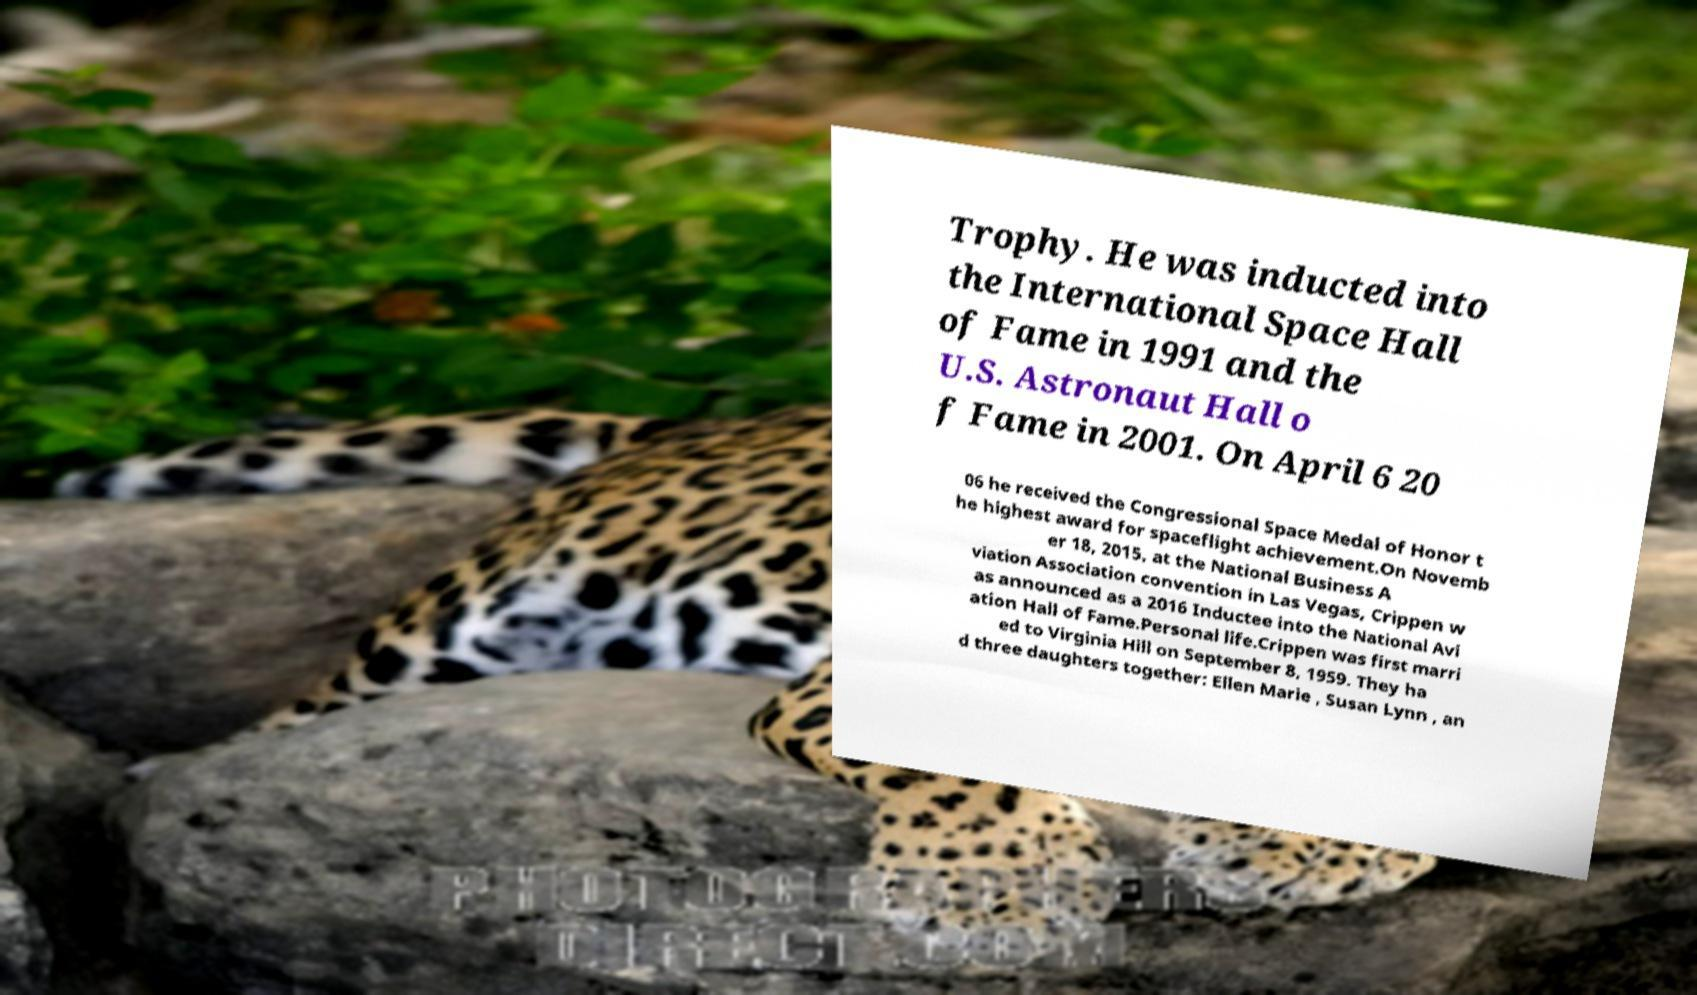Please read and relay the text visible in this image. What does it say? Trophy. He was inducted into the International Space Hall of Fame in 1991 and the U.S. Astronaut Hall o f Fame in 2001. On April 6 20 06 he received the Congressional Space Medal of Honor t he highest award for spaceflight achievement.On Novemb er 18, 2015, at the National Business A viation Association convention in Las Vegas, Crippen w as announced as a 2016 Inductee into the National Avi ation Hall of Fame.Personal life.Crippen was first marri ed to Virginia Hill on September 8, 1959. They ha d three daughters together: Ellen Marie , Susan Lynn , an 